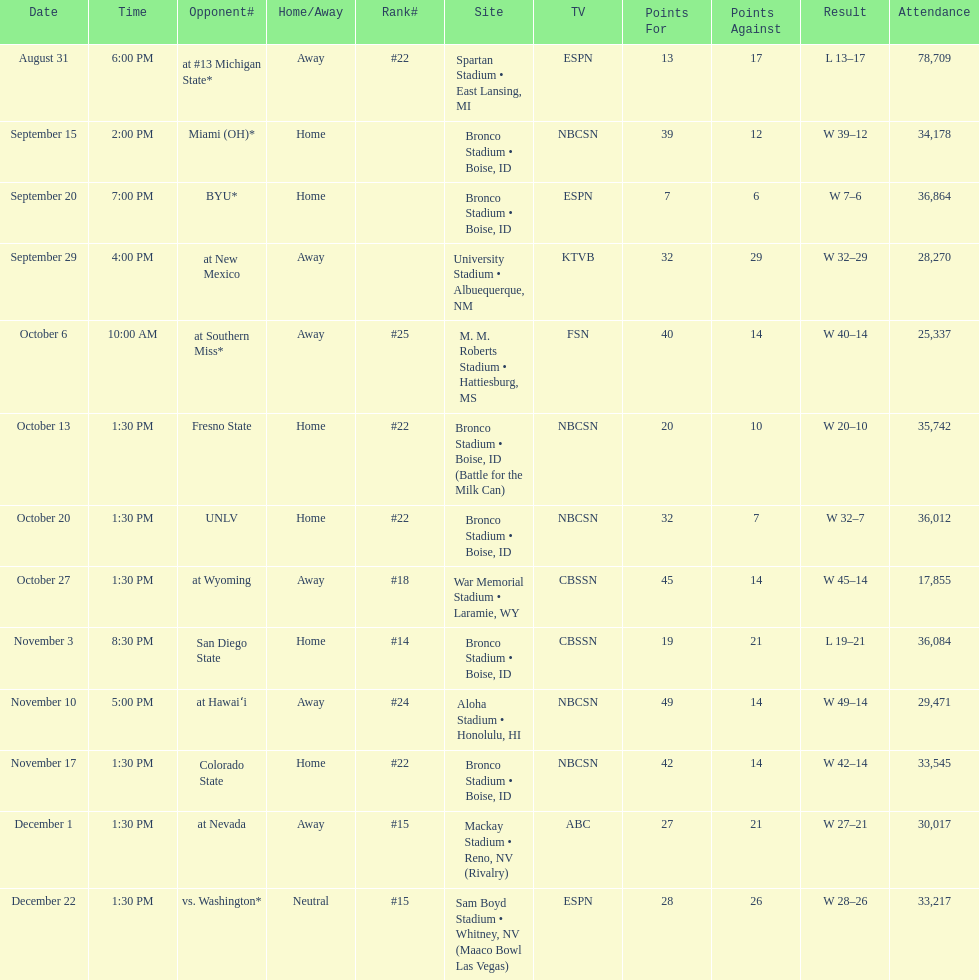Opponent broncos faced next after unlv Wyoming. 